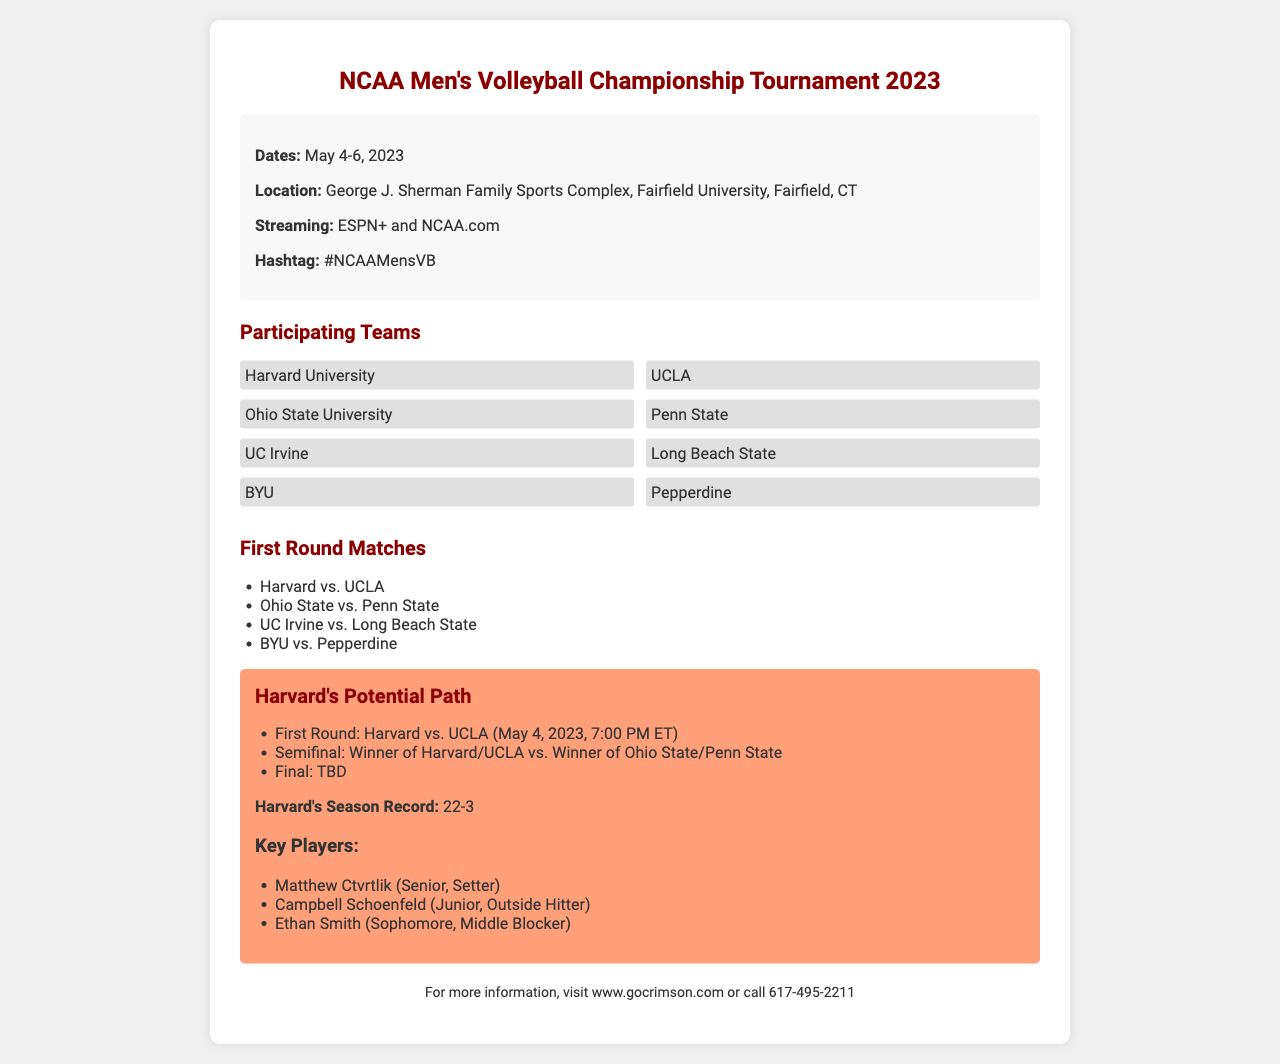what are the tournament dates? The tournament dates are mentioned clearly in the document as May 4-6, 2023.
Answer: May 4-6, 2023 where is the tournament being held? The location of the tournament is specified as George J. Sherman Family Sports Complex, Fairfield University, Fairfield, CT.
Answer: Fairfield, CT who is Harvard's opponent in the first round? The document lists Harvard's first-round match against UCLA.
Answer: UCLA what is Harvard's season record? Harvard's season record is highlighted in the document as 22-3.
Answer: 22-3 who are the key players for Harvard? The document features a list of key players including Matthew Ctvrtlik, Campbell Schoenfeld, and Ethan Smith.
Answer: Matthew Ctvrtlik, Campbell Schoenfeld, Ethan Smith which teams are participating in the tournament? The document enumerates the participating teams, including Harvard, UCLA, and others.
Answer: Harvard, UCLA, Ohio State, Penn State, UC Irvine, Long Beach State, BYU, Pepperdine what is the streaming service for the tournament? The document indicates that the tournament will be streamed on ESPN+ and NCAA.com.
Answer: ESPN+ and NCAA.com what is the time of Harvard's first match? The time for Harvard's first match against UCLA is stated as 7:00 PM ET.
Answer: 7:00 PM ET who will Harvard face in the semifinals if they win? The semifinals opponent for Harvard would be the winner of the Ohio State vs. Penn State match.
Answer: Ohio State/Penn State winner 